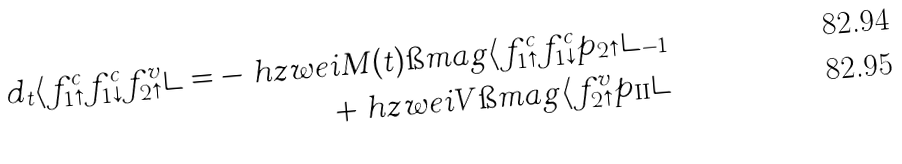<formula> <loc_0><loc_0><loc_500><loc_500>d _ { t } \langle f ^ { c } _ { 1 \uparrow } f ^ { c } _ { 1 \downarrow } f ^ { v } _ { 2 \uparrow } \rangle = - \ h z w e i M ( t ) \i m a g { \langle f ^ { c } _ { 1 \uparrow } f ^ { c } _ { 1 \downarrow } p _ { 2 \uparrow } \rangle _ { - 1 } } \\ + \ h z w e i V \i m a g { \langle f ^ { v } _ { 2 \uparrow } p _ { \text {II} } \rangle }</formula> 